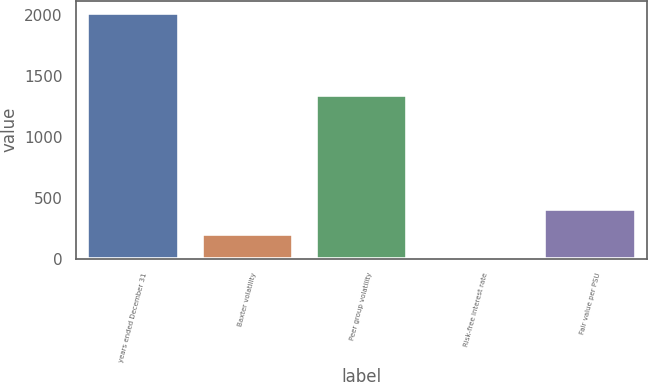Convert chart to OTSL. <chart><loc_0><loc_0><loc_500><loc_500><bar_chart><fcel>years ended December 31<fcel>Baxter volatility<fcel>Peer group volatility<fcel>Risk-free interest rate<fcel>Fair value per PSU<nl><fcel>2013<fcel>201.57<fcel>1338<fcel>0.3<fcel>402.84<nl></chart> 